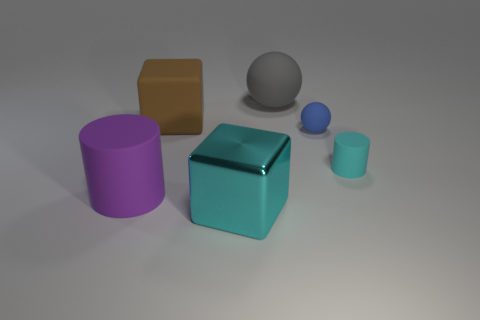Add 4 big brown blocks. How many objects exist? 10 Subtract all cylinders. How many objects are left? 4 Subtract all gray spheres. How many spheres are left? 1 Subtract all green cylinders. Subtract all red balls. How many cylinders are left? 2 Subtract all red balls. How many brown cylinders are left? 0 Subtract all large cyan blocks. Subtract all big purple rubber cylinders. How many objects are left? 4 Add 5 brown cubes. How many brown cubes are left? 6 Add 5 small blue metallic blocks. How many small blue metallic blocks exist? 5 Subtract 0 green blocks. How many objects are left? 6 Subtract 2 cubes. How many cubes are left? 0 